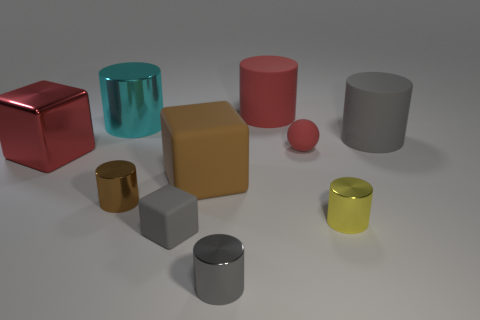How many red objects are small balls or large metal objects?
Your answer should be compact. 2. The matte thing that is in front of the brown object that is left of the big brown matte cube is what color?
Give a very brief answer. Gray. What material is the small thing that is the same color as the tiny cube?
Your answer should be compact. Metal. What is the color of the tiny thing that is behind the big metallic block?
Offer a terse response. Red. There is a gray rubber object left of the brown block; does it have the same size as the brown metallic object?
Give a very brief answer. Yes. There is a matte object that is the same color as the small cube; what size is it?
Your response must be concise. Large. Is there a green rubber cylinder of the same size as the brown rubber cube?
Make the answer very short. No. Is the color of the matte thing that is on the right side of the small red matte sphere the same as the tiny matte object in front of the matte sphere?
Your answer should be very brief. Yes. Are there any rubber cylinders of the same color as the sphere?
Your answer should be very brief. Yes. How many other objects are the same shape as the cyan object?
Your answer should be very brief. 5. 